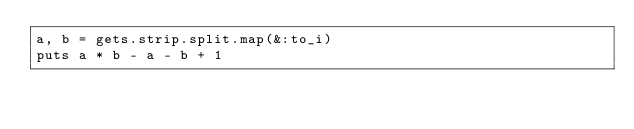Convert code to text. <code><loc_0><loc_0><loc_500><loc_500><_Ruby_>a, b = gets.strip.split.map(&:to_i)
puts a * b - a - b + 1</code> 